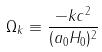<formula> <loc_0><loc_0><loc_500><loc_500>\Omega _ { k } \equiv \frac { - k c ^ { 2 } } { ( a _ { 0 } H _ { 0 } ) ^ { 2 } }</formula> 